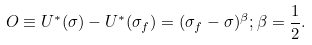Convert formula to latex. <formula><loc_0><loc_0><loc_500><loc_500>O \equiv U ^ { * } ( \sigma ) - U ^ { * } ( \sigma _ { f } ) = ( \sigma _ { f } - \sigma ) ^ { \beta } ; \beta = \frac { 1 } { 2 } .</formula> 